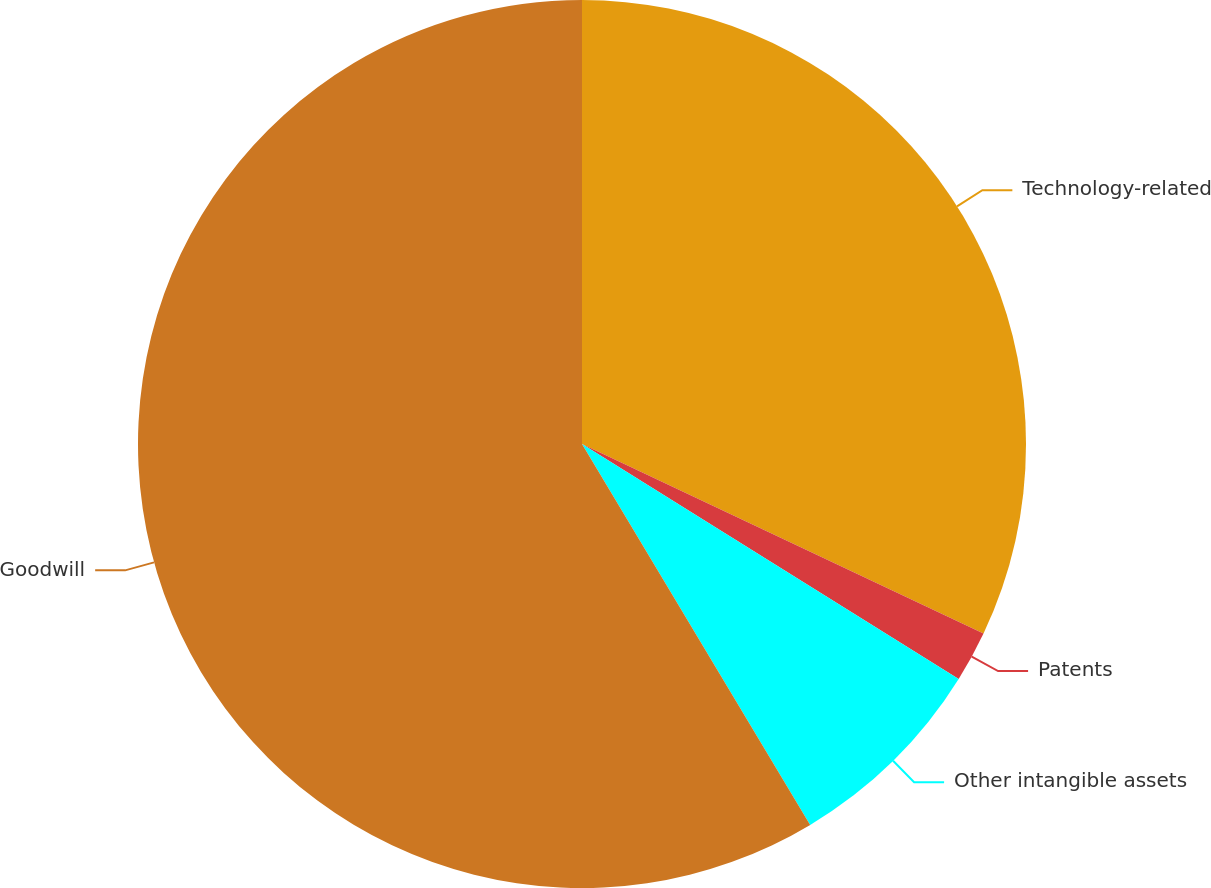Convert chart to OTSL. <chart><loc_0><loc_0><loc_500><loc_500><pie_chart><fcel>Technology-related<fcel>Patents<fcel>Other intangible assets<fcel>Goodwill<nl><fcel>32.02%<fcel>1.86%<fcel>7.53%<fcel>58.59%<nl></chart> 